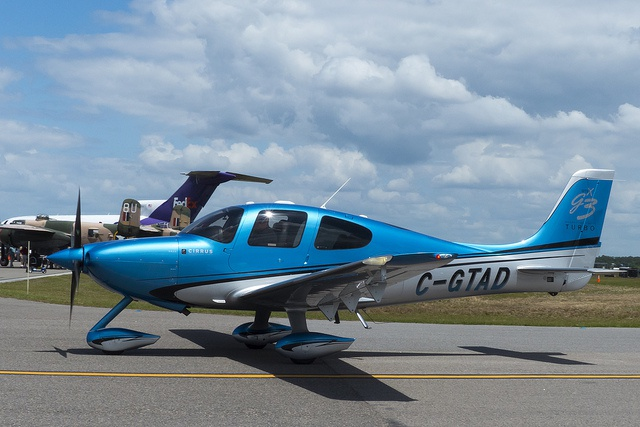Describe the objects in this image and their specific colors. I can see airplane in darkgray, black, teal, and gray tones, airplane in darkgray, black, gray, lightgray, and navy tones, people in darkgray, black, and gray tones, people in darkgray, black, and gray tones, and people in darkgray, black, and gray tones in this image. 